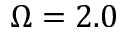<formula> <loc_0><loc_0><loc_500><loc_500>\Omega = 2 . 0</formula> 